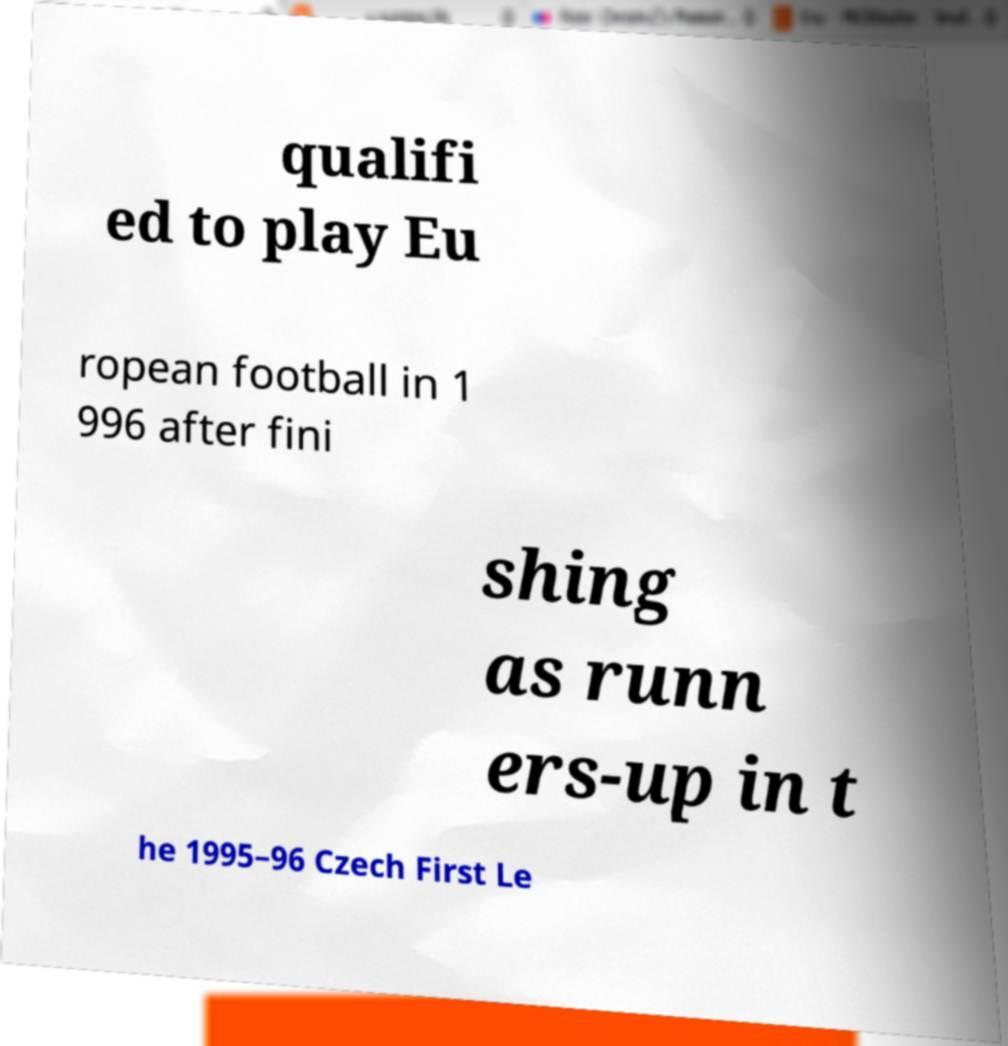Could you assist in decoding the text presented in this image and type it out clearly? qualifi ed to play Eu ropean football in 1 996 after fini shing as runn ers-up in t he 1995–96 Czech First Le 